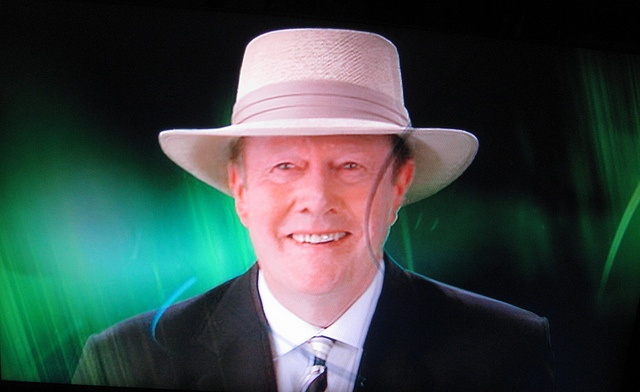Describe the objects in this image and their specific colors. I can see people in black, lavender, lightpink, and darkgray tones and tie in black, lavender, darkgray, and navy tones in this image. 